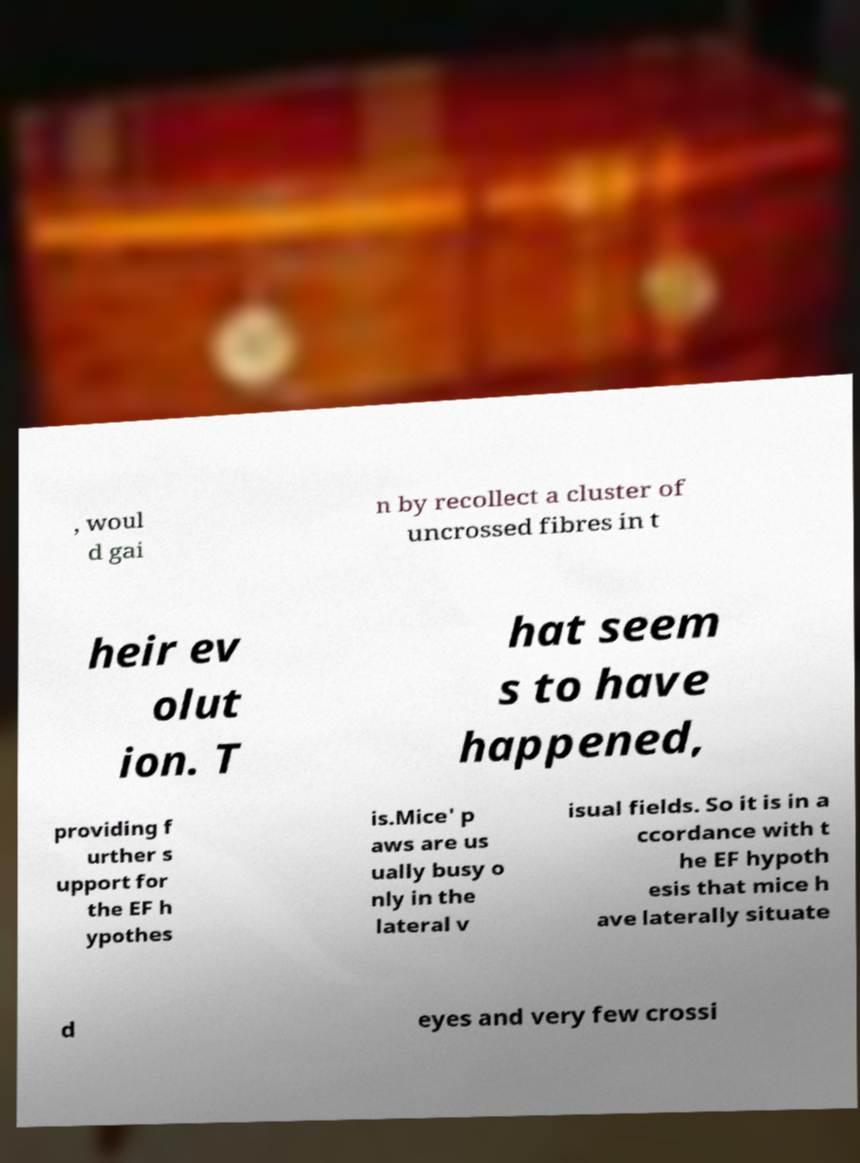Can you accurately transcribe the text from the provided image for me? , woul d gai n by recollect a cluster of uncrossed fibres in t heir ev olut ion. T hat seem s to have happened, providing f urther s upport for the EF h ypothes is.Mice' p aws are us ually busy o nly in the lateral v isual fields. So it is in a ccordance with t he EF hypoth esis that mice h ave laterally situate d eyes and very few crossi 